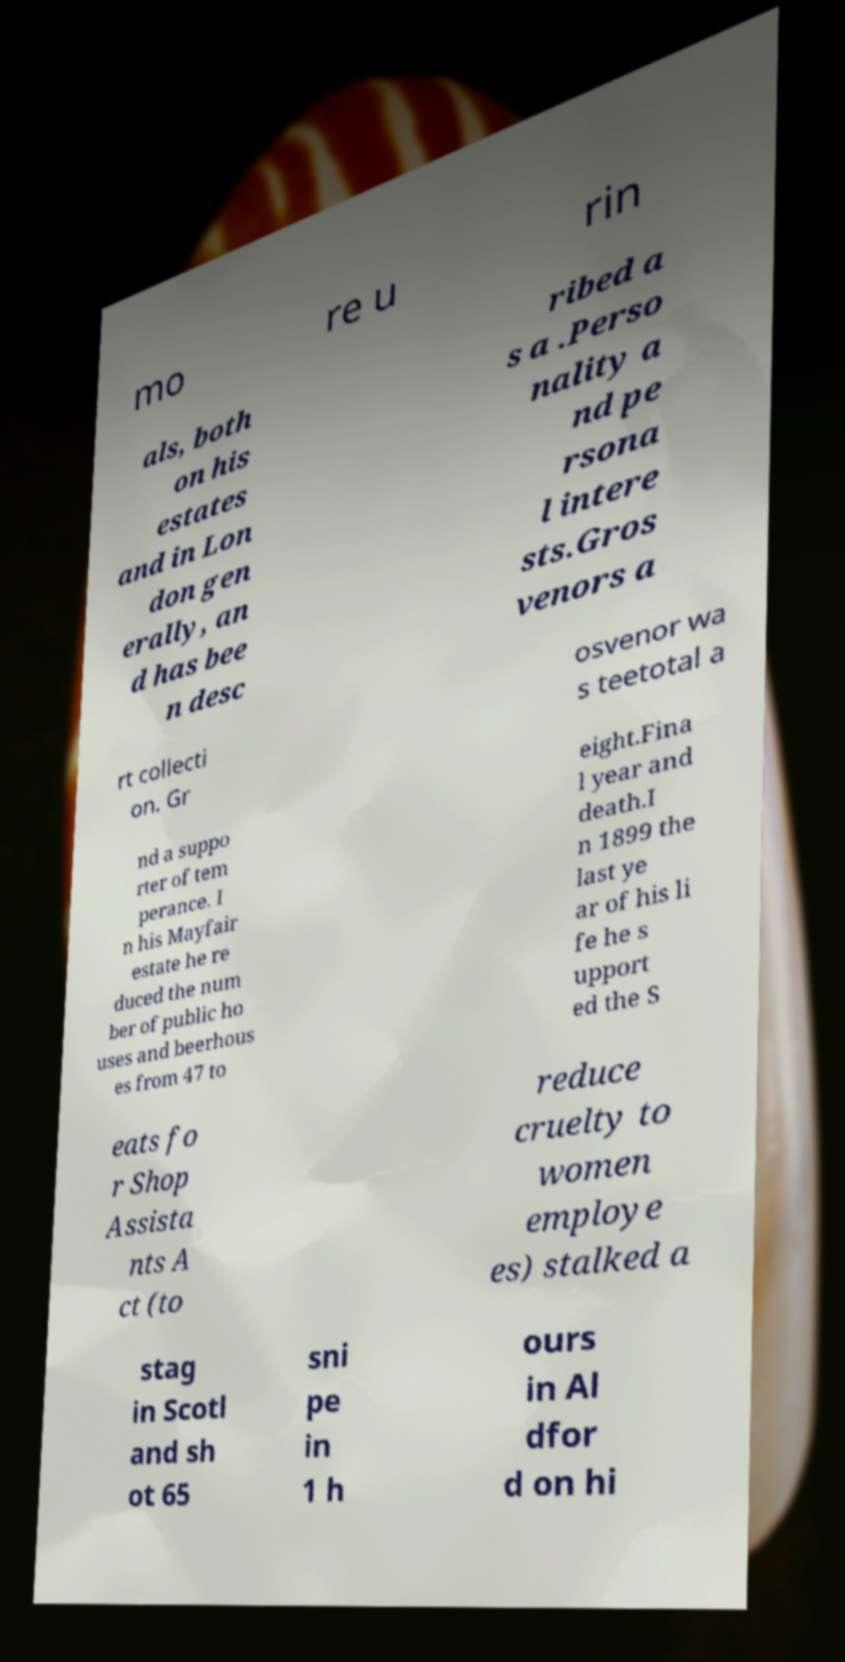Could you assist in decoding the text presented in this image and type it out clearly? mo re u rin als, both on his estates and in Lon don gen erally, an d has bee n desc ribed a s a .Perso nality a nd pe rsona l intere sts.Gros venors a rt collecti on. Gr osvenor wa s teetotal a nd a suppo rter of tem perance. I n his Mayfair estate he re duced the num ber of public ho uses and beerhous es from 47 to eight.Fina l year and death.I n 1899 the last ye ar of his li fe he s upport ed the S eats fo r Shop Assista nts A ct (to reduce cruelty to women employe es) stalked a stag in Scotl and sh ot 65 sni pe in 1 h ours in Al dfor d on hi 